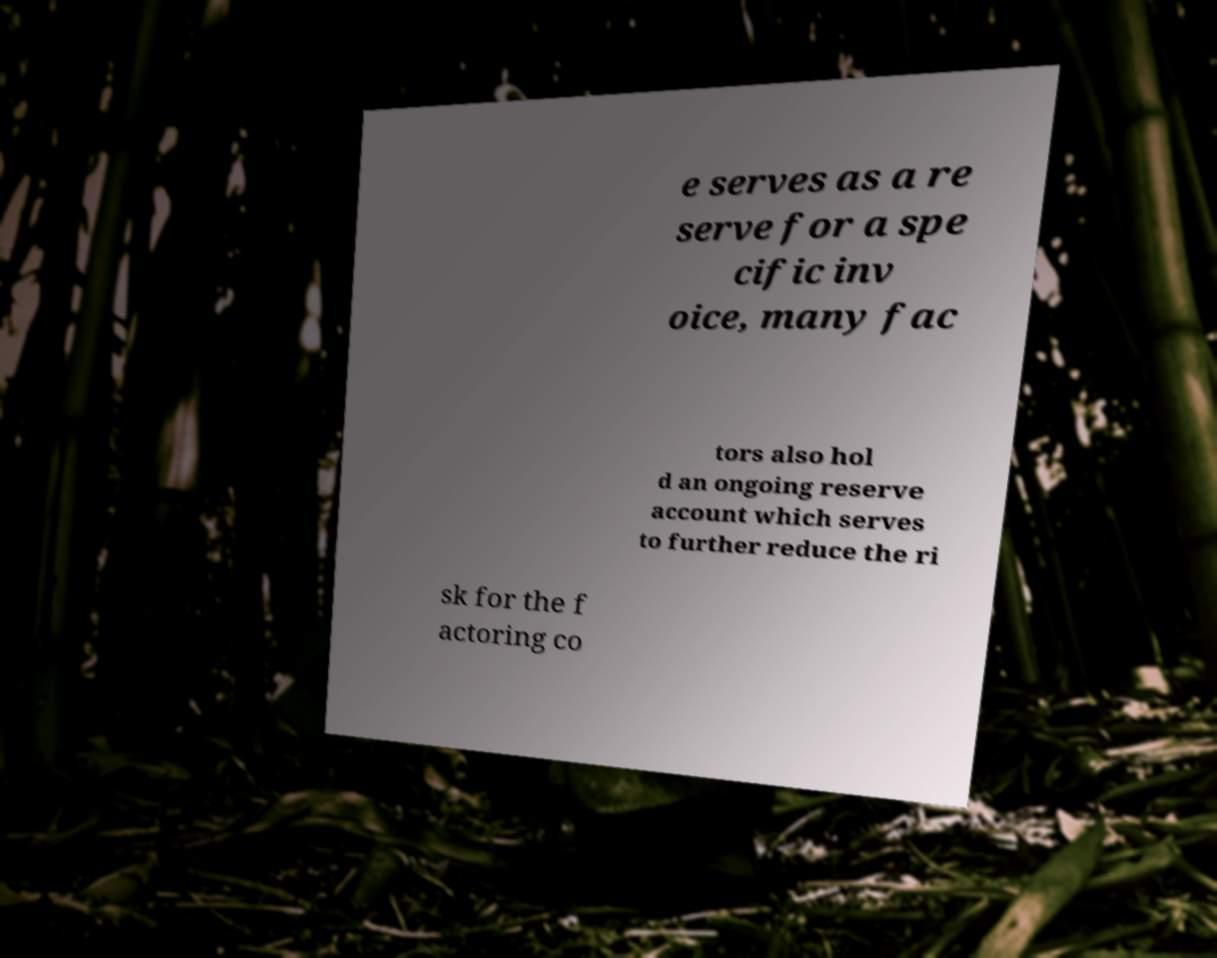Could you assist in decoding the text presented in this image and type it out clearly? e serves as a re serve for a spe cific inv oice, many fac tors also hol d an ongoing reserve account which serves to further reduce the ri sk for the f actoring co 